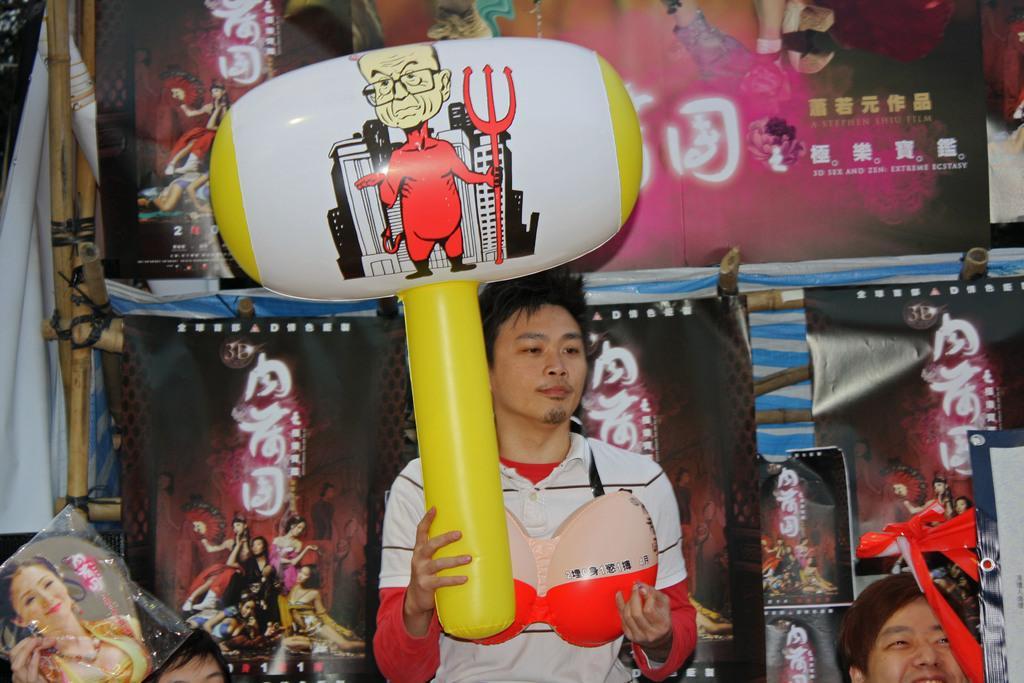Can you describe this image briefly? In the center of the image we can see a man standing and holding a balloon in his hand. In the background there are banners and we can see boards. At the bottom there are people. 